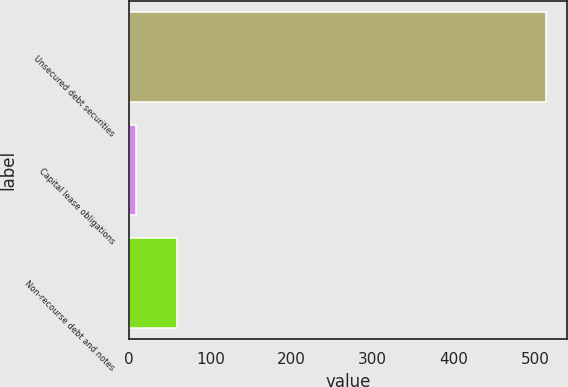Convert chart to OTSL. <chart><loc_0><loc_0><loc_500><loc_500><bar_chart><fcel>Unsecured debt securities<fcel>Capital lease obligations<fcel>Non-recourse debt and notes<nl><fcel>514<fcel>9<fcel>59.5<nl></chart> 